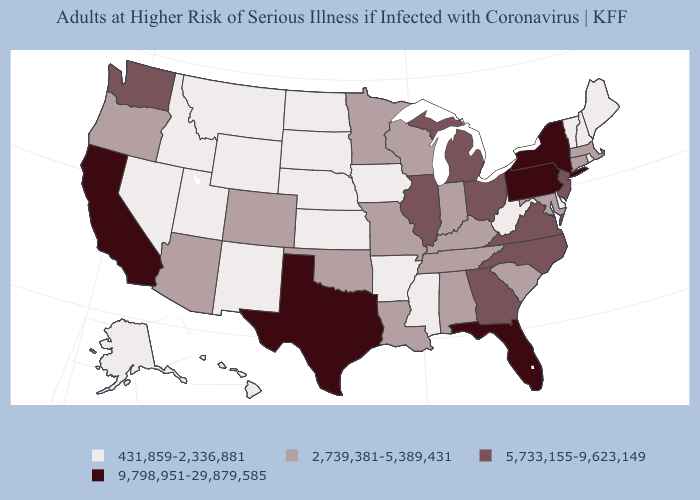What is the value of Connecticut?
Be succinct. 2,739,381-5,389,431. Does Florida have the highest value in the USA?
Concise answer only. Yes. What is the value of Rhode Island?
Give a very brief answer. 431,859-2,336,881. What is the value of West Virginia?
Short answer required. 431,859-2,336,881. Which states have the lowest value in the USA?
Write a very short answer. Alaska, Arkansas, Delaware, Hawaii, Idaho, Iowa, Kansas, Maine, Mississippi, Montana, Nebraska, Nevada, New Hampshire, New Mexico, North Dakota, Rhode Island, South Dakota, Utah, Vermont, West Virginia, Wyoming. What is the value of Delaware?
Concise answer only. 431,859-2,336,881. Among the states that border New Jersey , which have the highest value?
Give a very brief answer. New York, Pennsylvania. What is the highest value in states that border North Carolina?
Write a very short answer. 5,733,155-9,623,149. Among the states that border Iowa , does Wisconsin have the lowest value?
Write a very short answer. No. Name the states that have a value in the range 5,733,155-9,623,149?
Give a very brief answer. Georgia, Illinois, Michigan, New Jersey, North Carolina, Ohio, Virginia, Washington. Name the states that have a value in the range 2,739,381-5,389,431?
Short answer required. Alabama, Arizona, Colorado, Connecticut, Indiana, Kentucky, Louisiana, Maryland, Massachusetts, Minnesota, Missouri, Oklahoma, Oregon, South Carolina, Tennessee, Wisconsin. What is the highest value in the South ?
Short answer required. 9,798,951-29,879,585. Does Pennsylvania have the lowest value in the Northeast?
Answer briefly. No. Name the states that have a value in the range 2,739,381-5,389,431?
Answer briefly. Alabama, Arizona, Colorado, Connecticut, Indiana, Kentucky, Louisiana, Maryland, Massachusetts, Minnesota, Missouri, Oklahoma, Oregon, South Carolina, Tennessee, Wisconsin. Does the first symbol in the legend represent the smallest category?
Short answer required. Yes. 